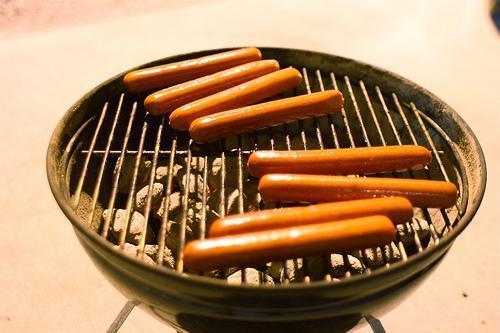How many grills are visible?
Give a very brief answer. 1. How many hot dogs are visible?
Give a very brief answer. 8. 